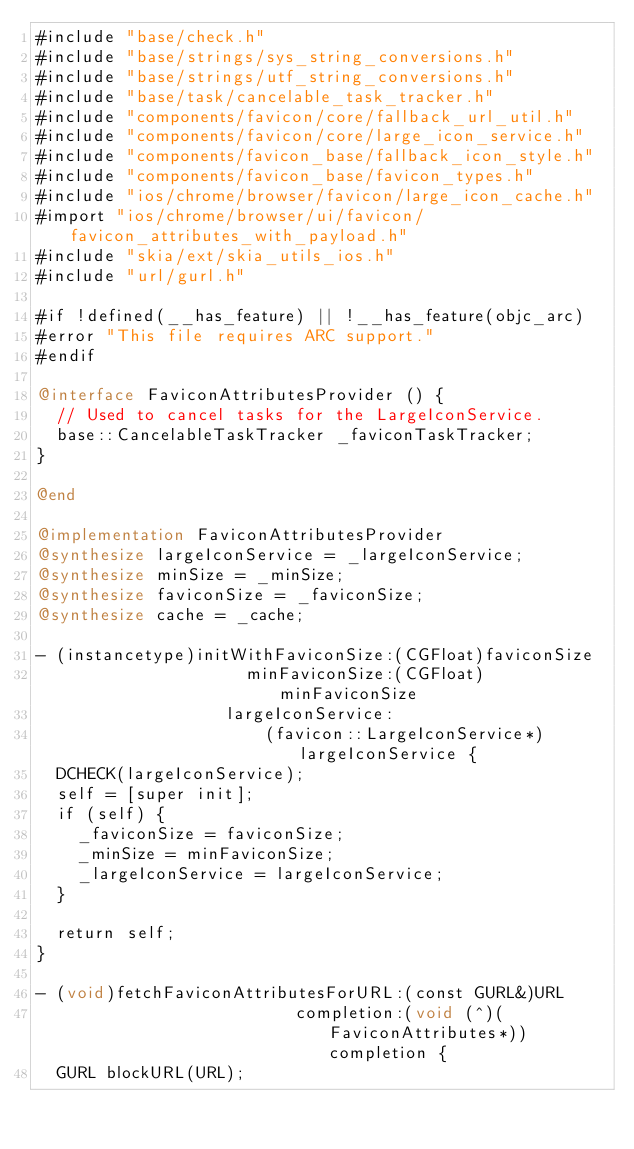<code> <loc_0><loc_0><loc_500><loc_500><_ObjectiveC_>#include "base/check.h"
#include "base/strings/sys_string_conversions.h"
#include "base/strings/utf_string_conversions.h"
#include "base/task/cancelable_task_tracker.h"
#include "components/favicon/core/fallback_url_util.h"
#include "components/favicon/core/large_icon_service.h"
#include "components/favicon_base/fallback_icon_style.h"
#include "components/favicon_base/favicon_types.h"
#include "ios/chrome/browser/favicon/large_icon_cache.h"
#import "ios/chrome/browser/ui/favicon/favicon_attributes_with_payload.h"
#include "skia/ext/skia_utils_ios.h"
#include "url/gurl.h"

#if !defined(__has_feature) || !__has_feature(objc_arc)
#error "This file requires ARC support."
#endif

@interface FaviconAttributesProvider () {
  // Used to cancel tasks for the LargeIconService.
  base::CancelableTaskTracker _faviconTaskTracker;
}

@end

@implementation FaviconAttributesProvider
@synthesize largeIconService = _largeIconService;
@synthesize minSize = _minSize;
@synthesize faviconSize = _faviconSize;
@synthesize cache = _cache;

- (instancetype)initWithFaviconSize:(CGFloat)faviconSize
                     minFaviconSize:(CGFloat)minFaviconSize
                   largeIconService:
                       (favicon::LargeIconService*)largeIconService {
  DCHECK(largeIconService);
  self = [super init];
  if (self) {
    _faviconSize = faviconSize;
    _minSize = minFaviconSize;
    _largeIconService = largeIconService;
  }

  return self;
}

- (void)fetchFaviconAttributesForURL:(const GURL&)URL
                          completion:(void (^)(FaviconAttributes*))completion {
  GURL blockURL(URL);</code> 